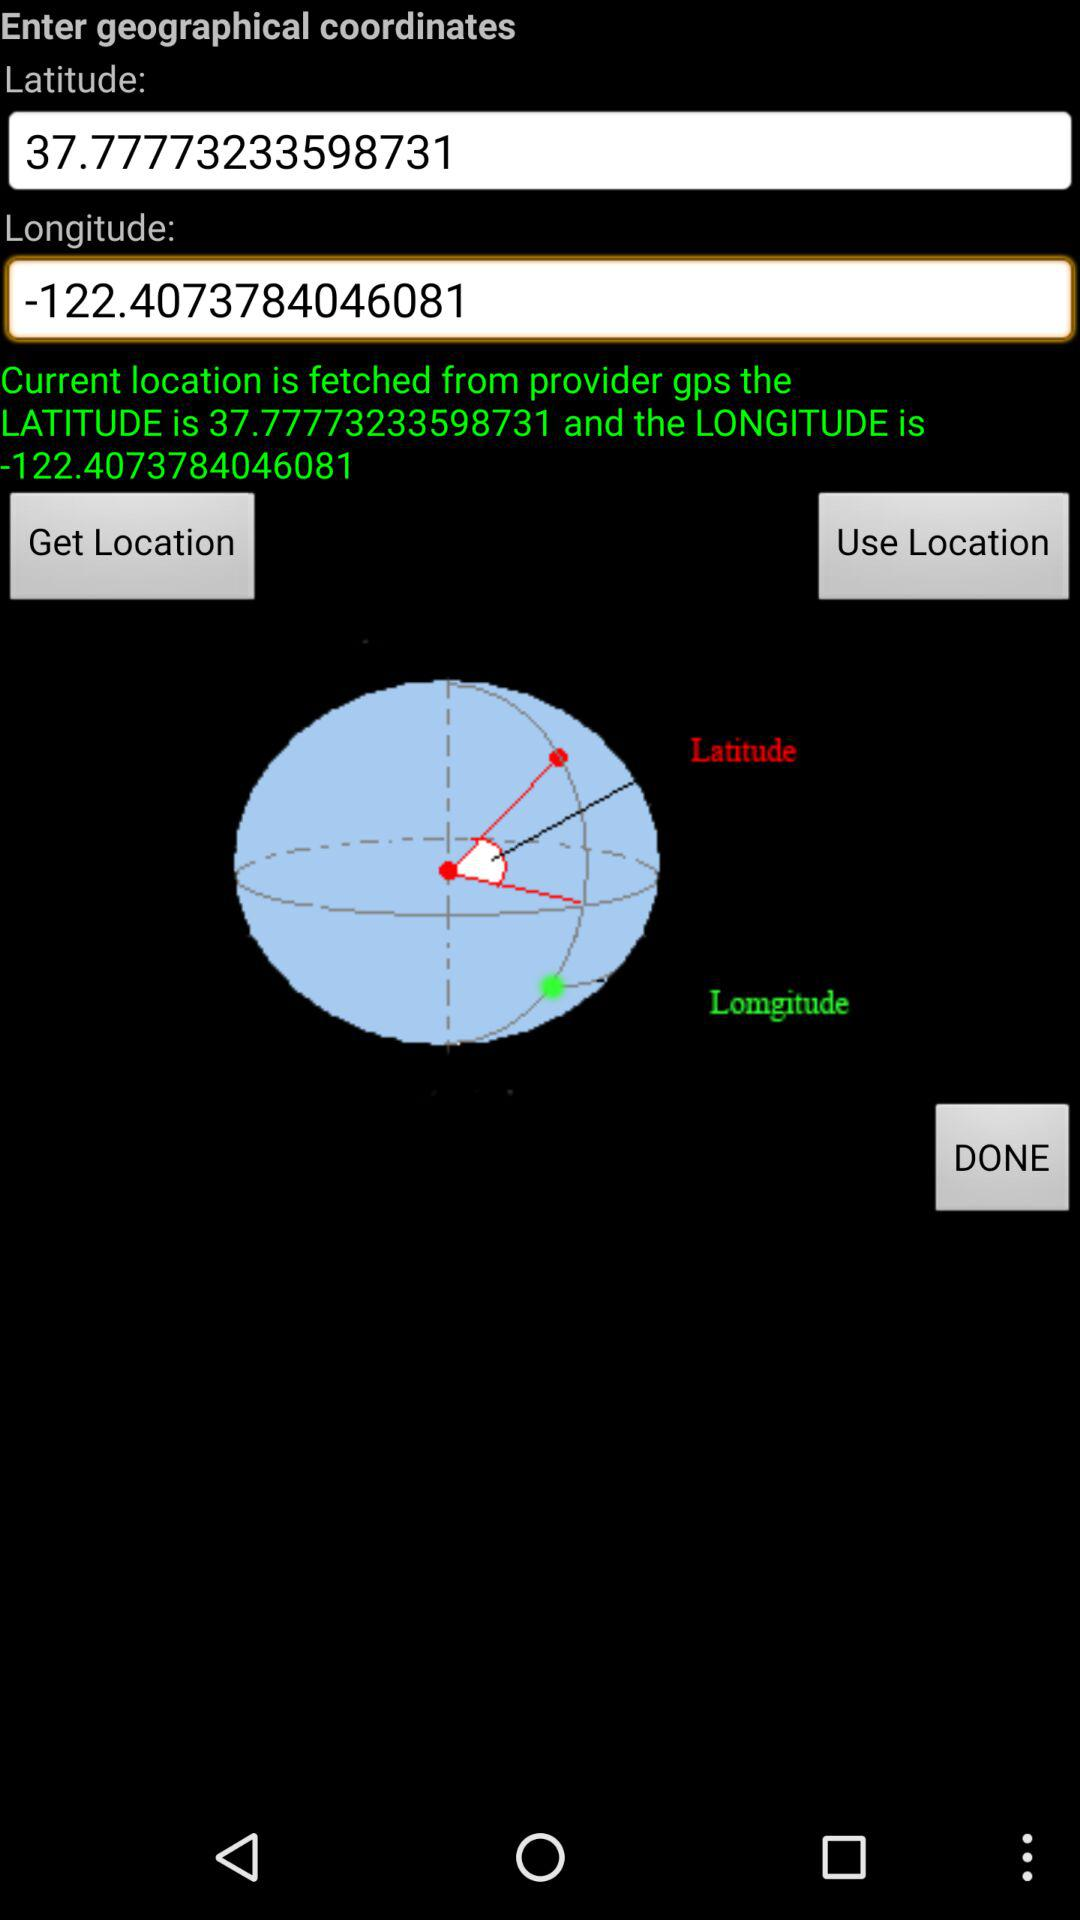What is the given longitude? The given longitude is -122.4073784046081. 